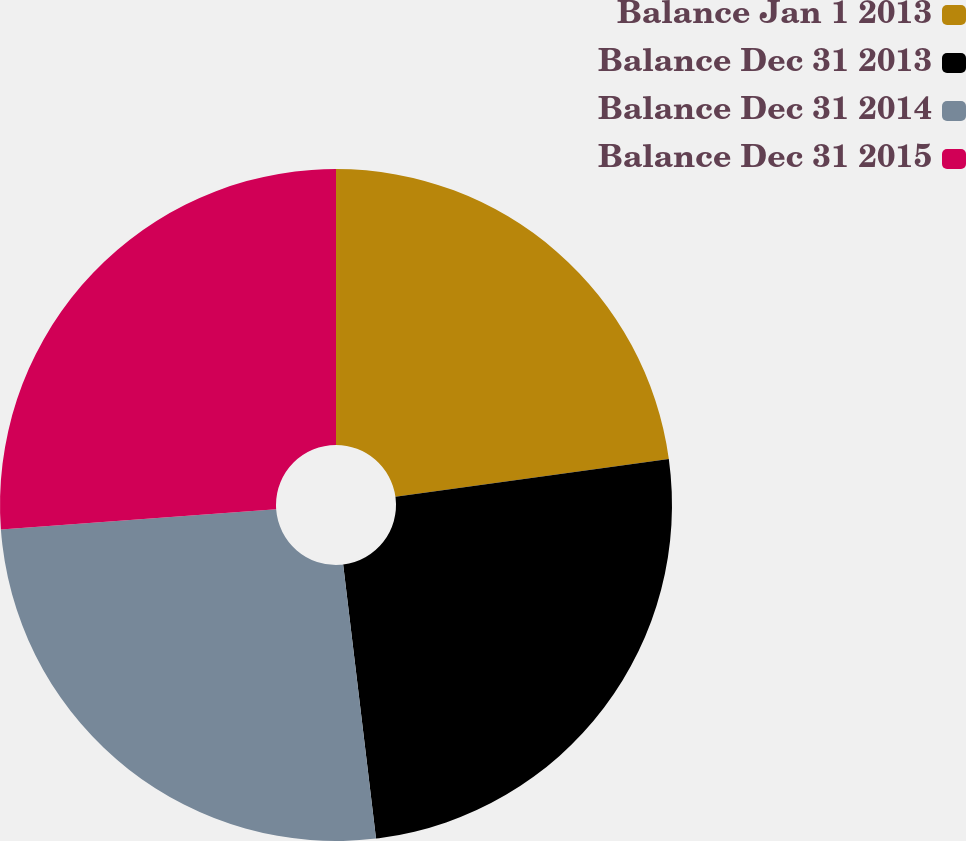<chart> <loc_0><loc_0><loc_500><loc_500><pie_chart><fcel>Balance Jan 1 2013<fcel>Balance Dec 31 2013<fcel>Balance Dec 31 2014<fcel>Balance Dec 31 2015<nl><fcel>22.81%<fcel>25.29%<fcel>25.74%<fcel>26.16%<nl></chart> 